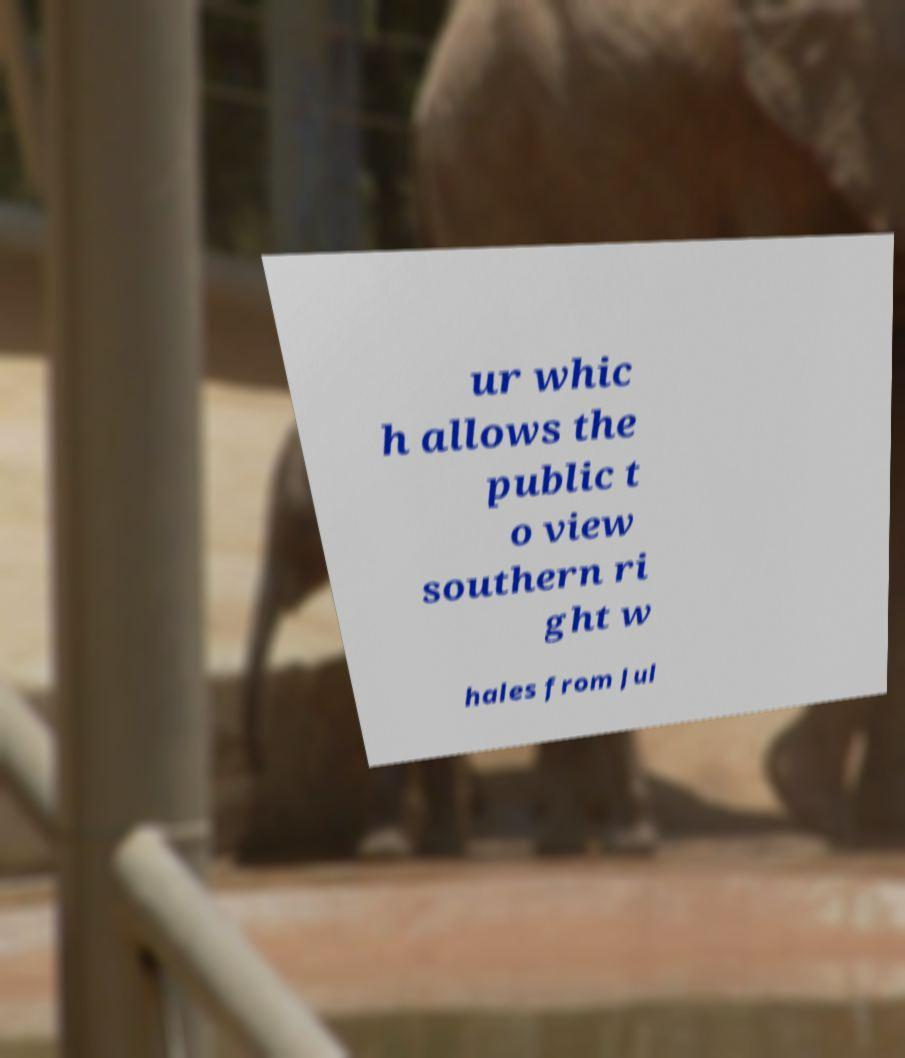Please identify and transcribe the text found in this image. ur whic h allows the public t o view southern ri ght w hales from Jul 